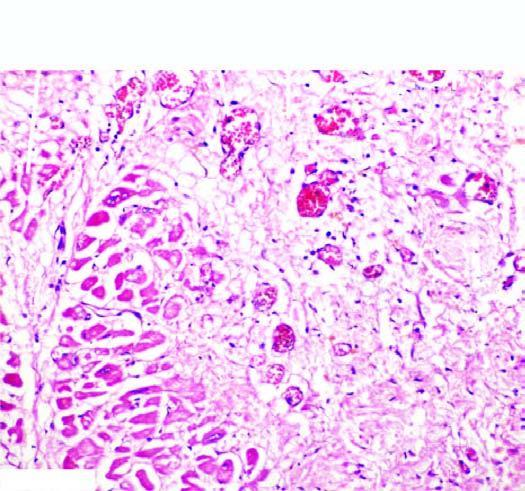what shows ingrowth of inflammatory granulation tissue?
Answer the question using a single word or phrase. The infarcted area 